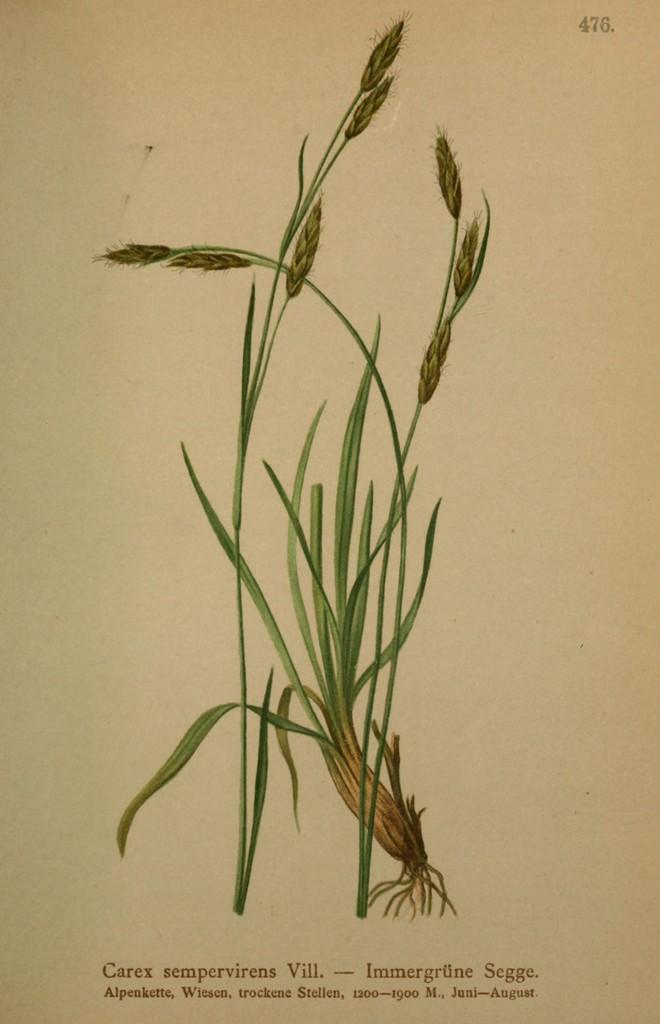Describe this image in one or two sentences. It is a picture from the page of a book,there is an image of a plant in the page. 